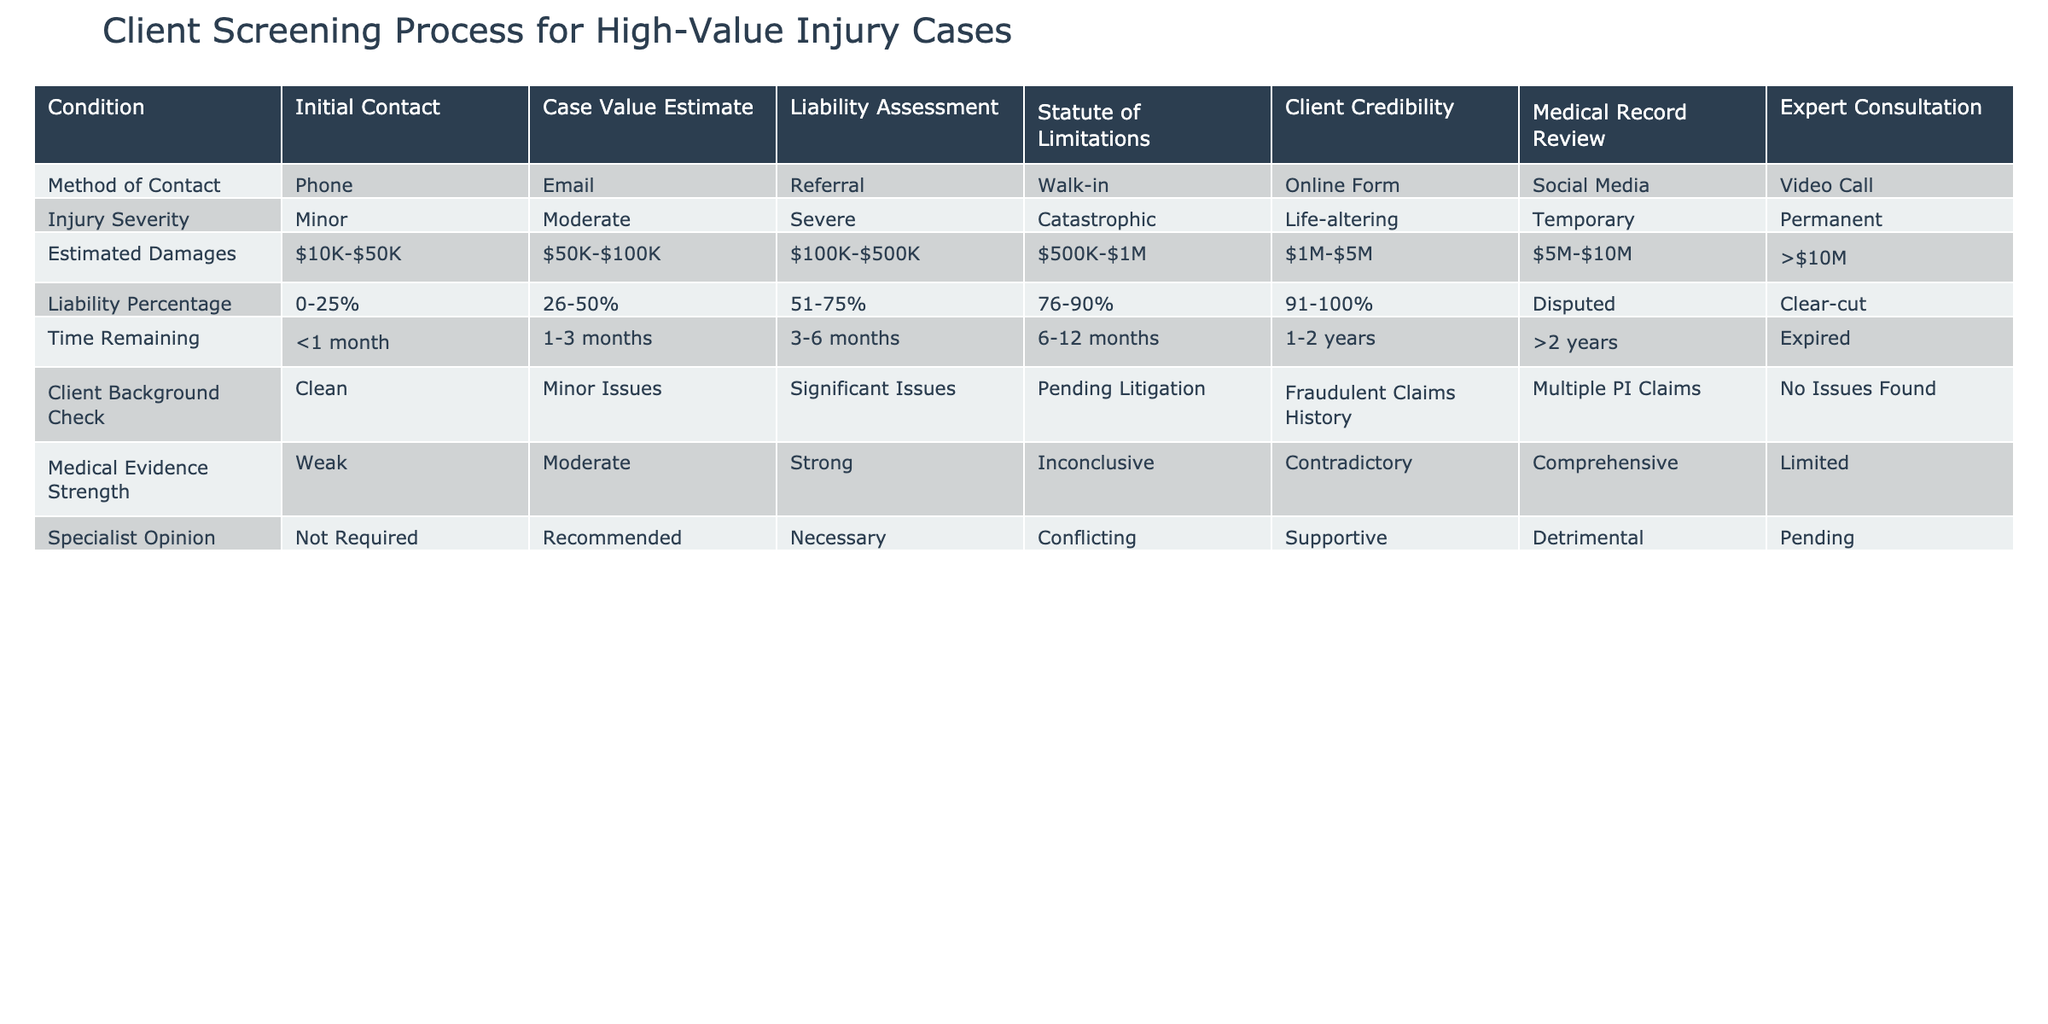What are the methods of contact listed in the table? The table presents a column for the "Method of Contact," which includes Phone, Email, Referral, Walk-in, Online Form, Social Media, and Video Call. These methods can be seen directly under the corresponding header in the table.
Answer: Phone, Email, Referral, Walk-in, Online Form, Social Media, Video Call What is the estimated case value range classified as 'Moderate'? According to the table under 'Estimated Damages', the range classified as 'Moderate' is between $50K and $100K. This can be identified by looking at the row under the 'Estimated Damages' heading.
Answer: $50K-$100K Is a 'Strong' medical evidence strength related to any type of liability percentage? Yes, a 'Strong' medical evidence strength can be linked to any type of liability percentage. However, without specific data that indicates an exact correlation in the table, it's logical to conclude that 'Strong' medical evidence would support higher liability percentages in general.
Answer: Yes How many methods of contact are associated with 'Catastrophic' injury severity level? There are no restrictions on the methods of contact for any specific injury severity level mentioned in the table; thus, all listed methods (Phone, Email, Referral, Walk-in, Online Form, Social Media, Video Call) are available for 'Catastrophic' injury cases. Since there are 7 methods listed, that’s the answer.
Answer: 7 What would be the average estimated damages for cases categorized between '$100K-$500K' and '$500K-$1M'? The two categorized damages are '$100K-$500K' and '$500K-$1M'. To find the average, we need to identify midpoints: for '$100K-$500K', the midpoint is $300K, and for '$500K-$1M', it is $750K. Thus, the average is (300K + 750K) / 2 = 525K.
Answer: $525K Does the table indicate that having 'Significant Issues' in the client background is a concern? Yes, 'Significant Issues' in the client background check may indicate potential risks and concerns in managing the case based on legal history, as outlined in the column for Client Background Check.
Answer: Yes If a client is categorized under 'Expired' statute of limitations, is it likely this case can proceed legally? No, if a case falls under the 'Expired' statute of limitations, it signifies that it is no longer valid for legal action to be pursued. Therefore, such cases typically cannot proceed.
Answer: No Which specialist opinion is categorized as 'Necessary'? The table specifically lists 'Necessary' under the Specialist Opinion column, indicating that cases requiring specialist analysis fall under this classification, but there are no further details on specific cases or conditions.
Answer: Necessary What comparison can you make regarding medical evidence strength between 'Weak' and 'Comprehensive'? 'Weak' medical evidence strength suggests limited support for a case, while 'Comprehensive' indicates strong and thorough support. Therefore, the difference indicates a potential outcome favoring claims with 'Comprehensive' medical evidence compared to those with 'Weak' evidence, which may be less favorable.
Answer: Comprehensive is better than Weak 